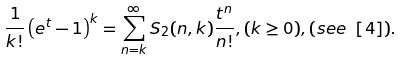<formula> <loc_0><loc_0><loc_500><loc_500>\frac { 1 } { k ! } \left ( e ^ { t } - 1 \right ) ^ { k } = \sum _ { n = k } ^ { \infty } S _ { 2 } ( n , k ) \frac { t ^ { n } } { n ! } , ( k \geq 0 ) , ( s e e \ [ 4 ] ) .</formula> 